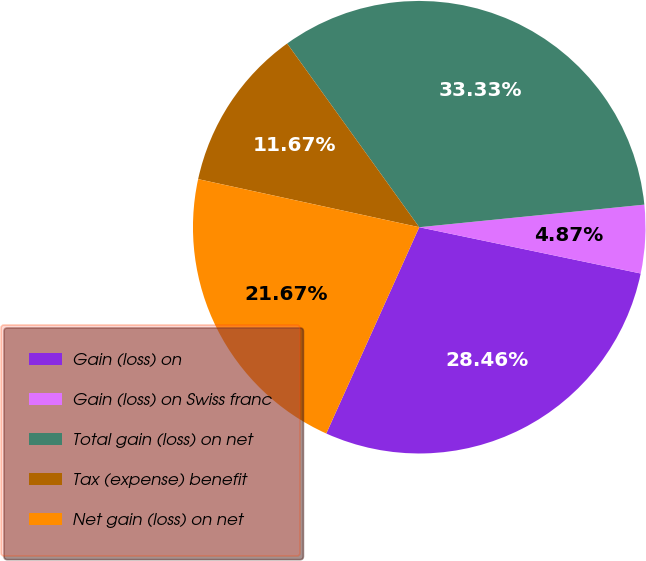<chart> <loc_0><loc_0><loc_500><loc_500><pie_chart><fcel>Gain (loss) on<fcel>Gain (loss) on Swiss franc<fcel>Total gain (loss) on net<fcel>Tax (expense) benefit<fcel>Net gain (loss) on net<nl><fcel>28.46%<fcel>4.87%<fcel>33.33%<fcel>11.67%<fcel>21.67%<nl></chart> 